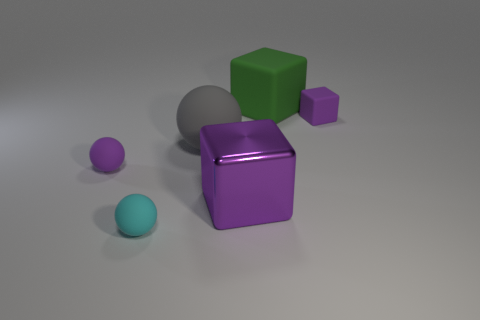Add 2 tiny matte objects. How many objects exist? 8 Subtract all tiny balls. How many balls are left? 1 Add 5 small purple spheres. How many small purple spheres are left? 6 Add 1 red matte balls. How many red matte balls exist? 1 Subtract all purple cubes. How many cubes are left? 1 Subtract 0 cyan cubes. How many objects are left? 6 Subtract 2 blocks. How many blocks are left? 1 Subtract all green cubes. Subtract all red cylinders. How many cubes are left? 2 Subtract all blue cubes. How many blue spheres are left? 0 Subtract all green matte objects. Subtract all green blocks. How many objects are left? 4 